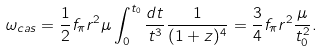<formula> <loc_0><loc_0><loc_500><loc_500>\omega _ { c a s } = \frac { 1 } { 2 } f _ { \pi } r ^ { 2 } \mu \int _ { 0 } ^ { t _ { 0 } } \frac { d t } { t ^ { 3 } } \frac { 1 } { ( 1 + z ) ^ { 4 } } = \frac { 3 } { 4 } f _ { \pi } r ^ { 2 } \frac { \mu } { t _ { 0 } ^ { 2 } } .</formula> 